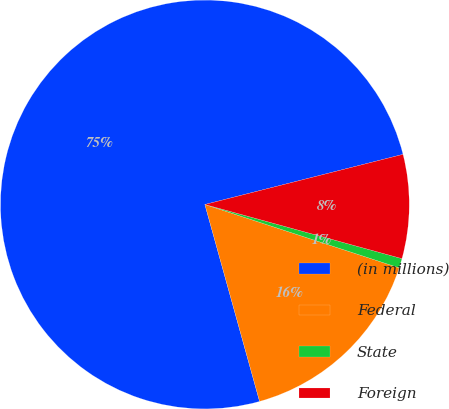Convert chart. <chart><loc_0><loc_0><loc_500><loc_500><pie_chart><fcel>(in millions)<fcel>Federal<fcel>State<fcel>Foreign<nl><fcel>75.36%<fcel>15.67%<fcel>0.75%<fcel>8.21%<nl></chart> 